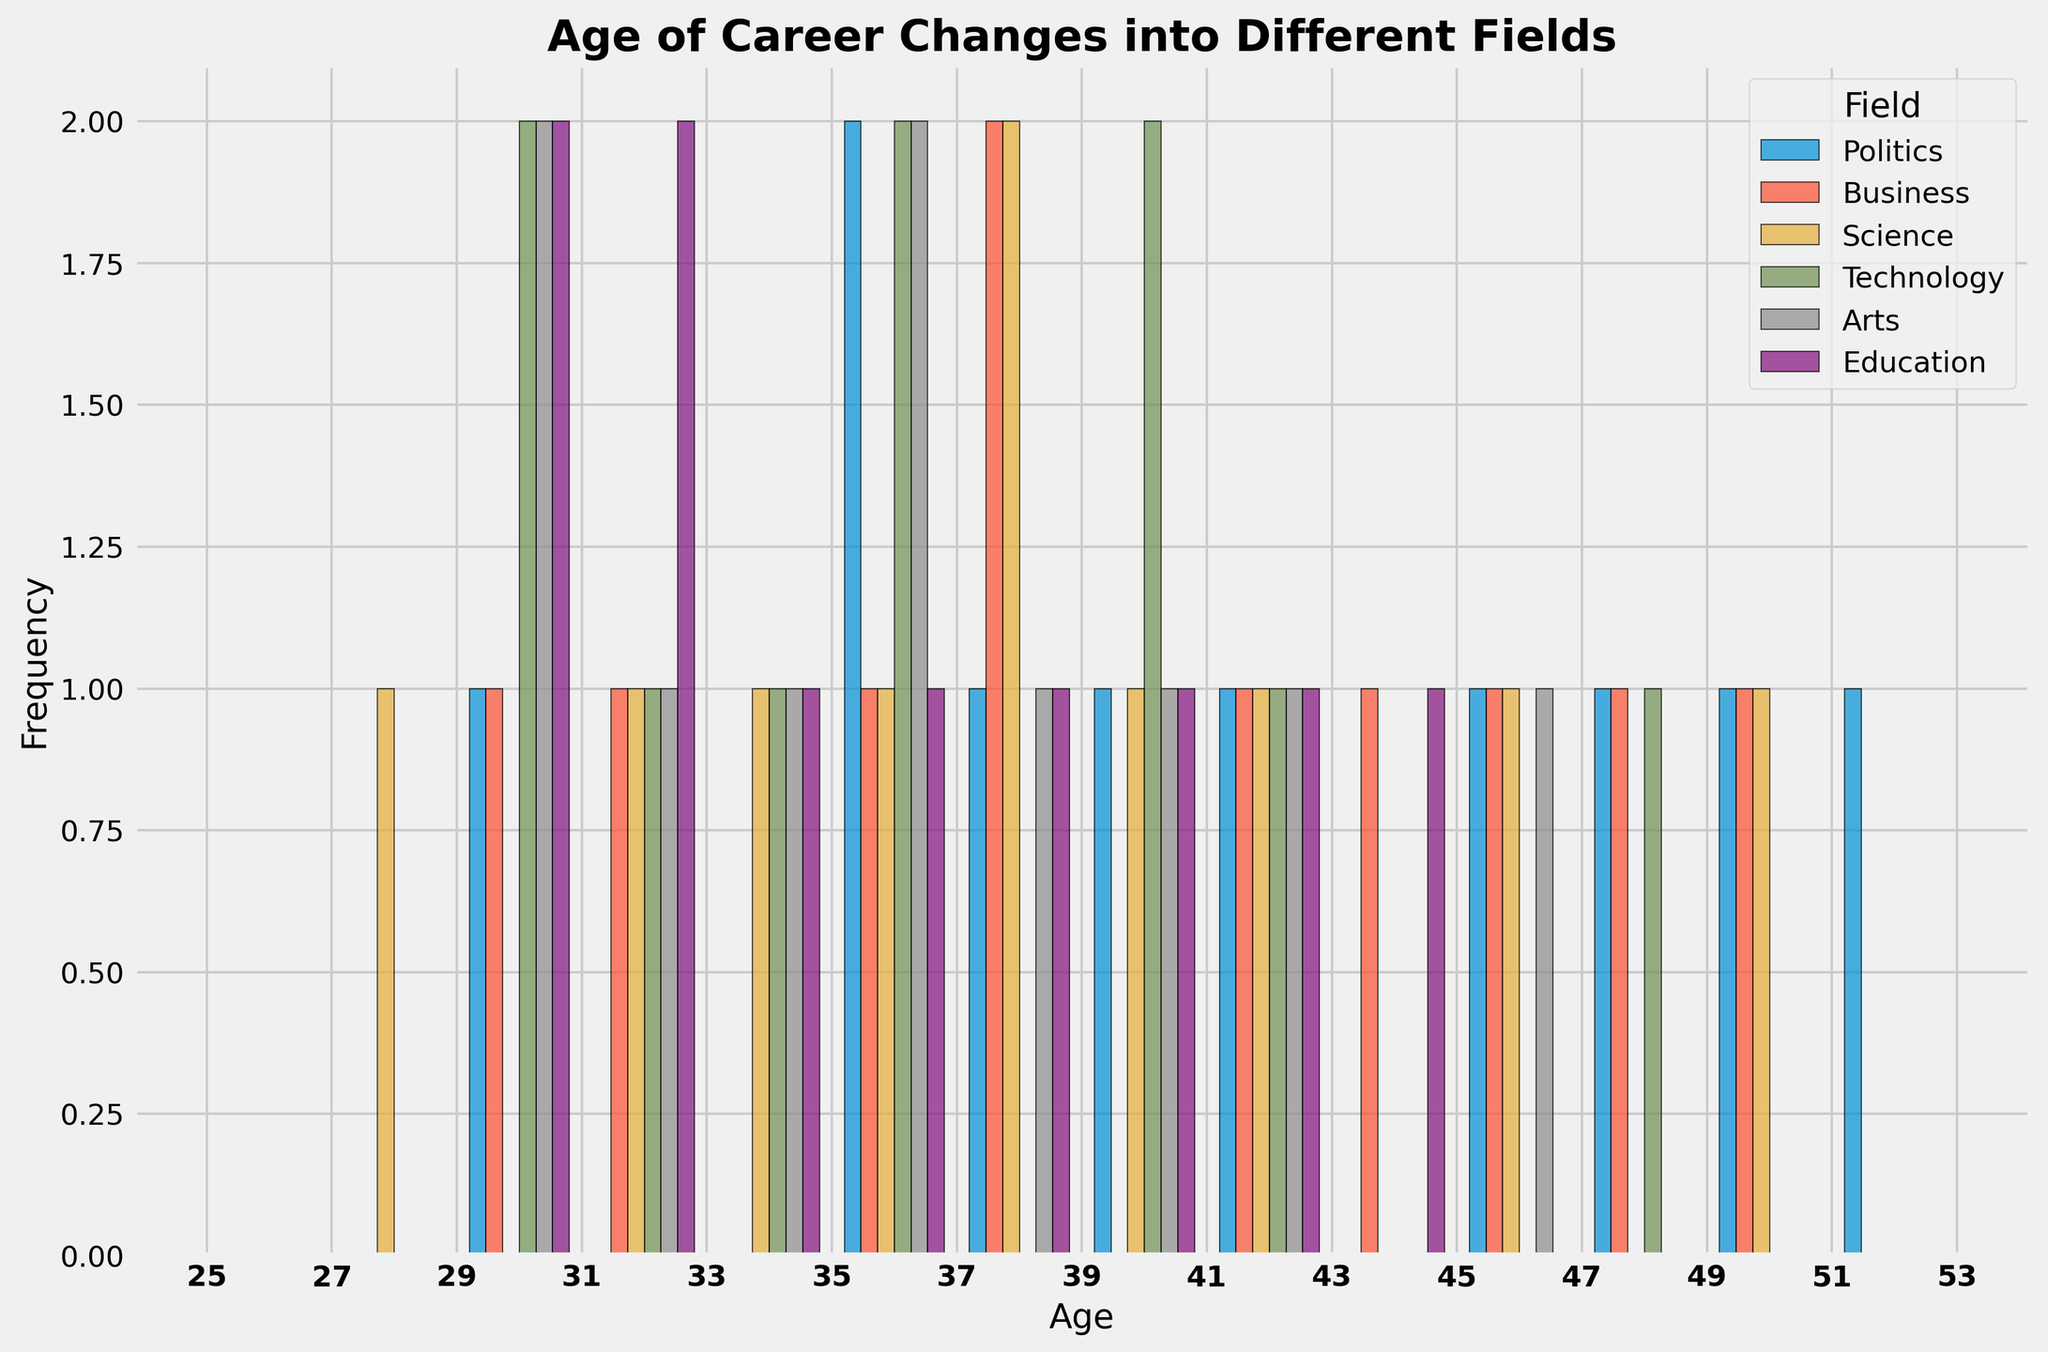What is the most common age range for career changes into politics? Look at the histogram bars labeled for politics. Identify the age range with the highest frequency.
Answer: 40-42 Which field has the youngest career changers on average? Compare the peaks of age distributions across different fields. The field with the peak in lower age ranges has the youngest average.
Answer: Science How does the frequency of career changes into technology at ages 30-32 compare with 38-40? Count the frequency of career changes in technology bars for the ages 30-32 and compare with the count for 38-40.
Answer: 2 vs 2 Which field shows the greatest spread in the age of career changes, and how can you tell? The field with the widest range in the spread of bars indicates the greatest age diversity. Compare the range of ages covered by the histogram edges for each field.
Answer: Politics Among the fields, who made the most career changes at age 35? Identify the height of the histogram bars at age 35 for each field. The tallest bar represents the field with the most career changes.
Answer: Education What’s the difference between the highest frequency of career changes in technology and arts? Find the tallest bars for technology and arts, then subtract the frequency of the arts from the frequency of technology.
Answer: 1 Which field has the closest frequency distribution for the age of career changes to politics? Visually compare the other fields' histogram bars' overall shape and spread to that of politics. The most similar one is the answer.
Answer: Education What is the trend in the number of career changes into business as age increases? Observe the data points in the histogram for business. You'll see trends by noting whether the bars increase, decrease, or remain constant as you move from left to right along the x-axis.
Answer: Increases then decreases How many career changes into science happened between 30 and 40? Count the frequency of the histogram bars for science between ages 30 and 40. Sum these counts.
Answer: 6 At which age does arts see the highest peak in career changes, and how does it compare to science? Find the age with the highest bar in arts and compare the height (frequency) of words at the same age in science.
Answer: 35; same 